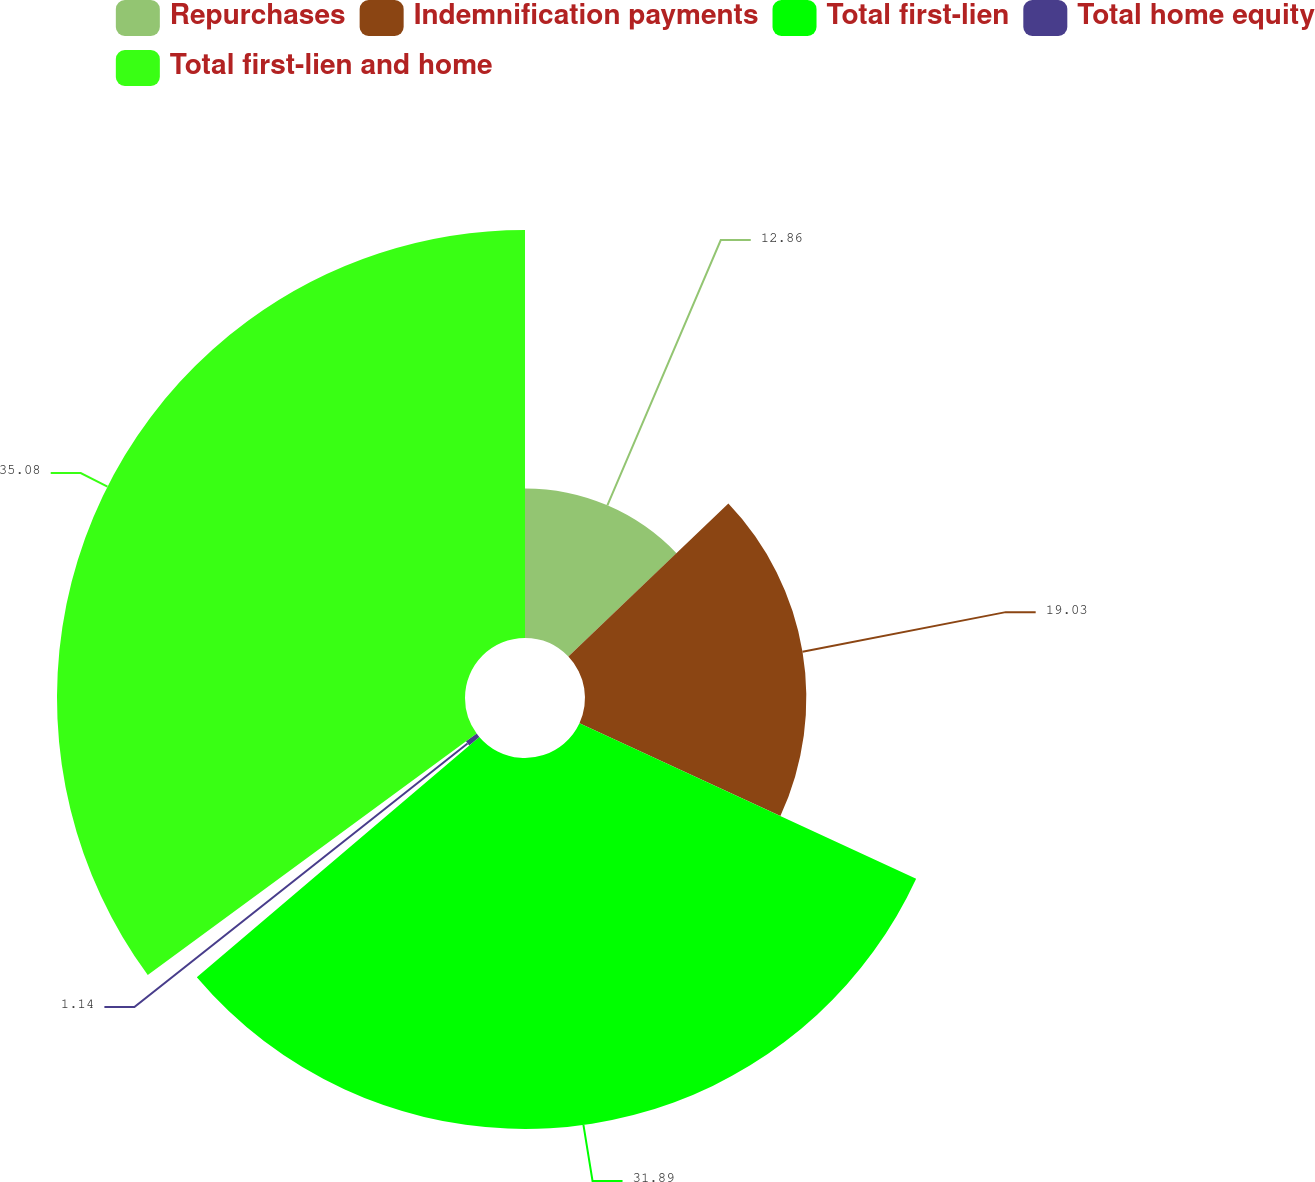Convert chart to OTSL. <chart><loc_0><loc_0><loc_500><loc_500><pie_chart><fcel>Repurchases<fcel>Indemnification payments<fcel>Total first-lien<fcel>Total home equity<fcel>Total first-lien and home<nl><fcel>12.86%<fcel>19.03%<fcel>31.89%<fcel>1.14%<fcel>35.08%<nl></chart> 